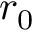<formula> <loc_0><loc_0><loc_500><loc_500>r _ { 0 }</formula> 